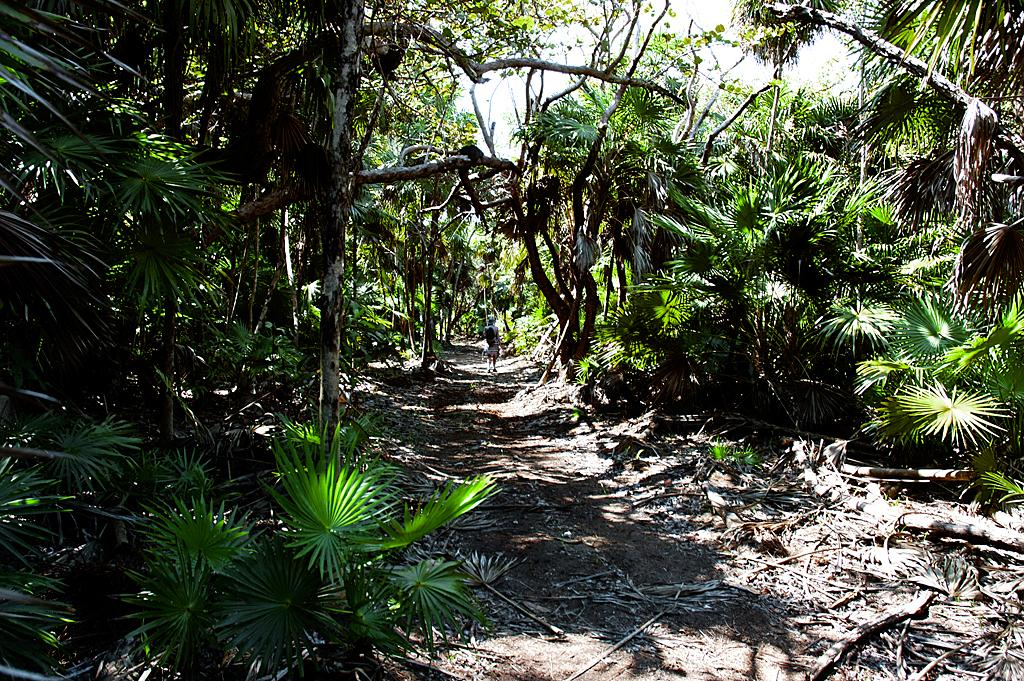What type of vegetation can be seen in the image? There are plants and trees in the image. What can be seen in the background of the image? The sky is visible in the background of the image. Where is the sheet located in the image? There is no sheet present in the image. What type of animals can be seen at the zoo in the image? There is no zoo present in the image. 